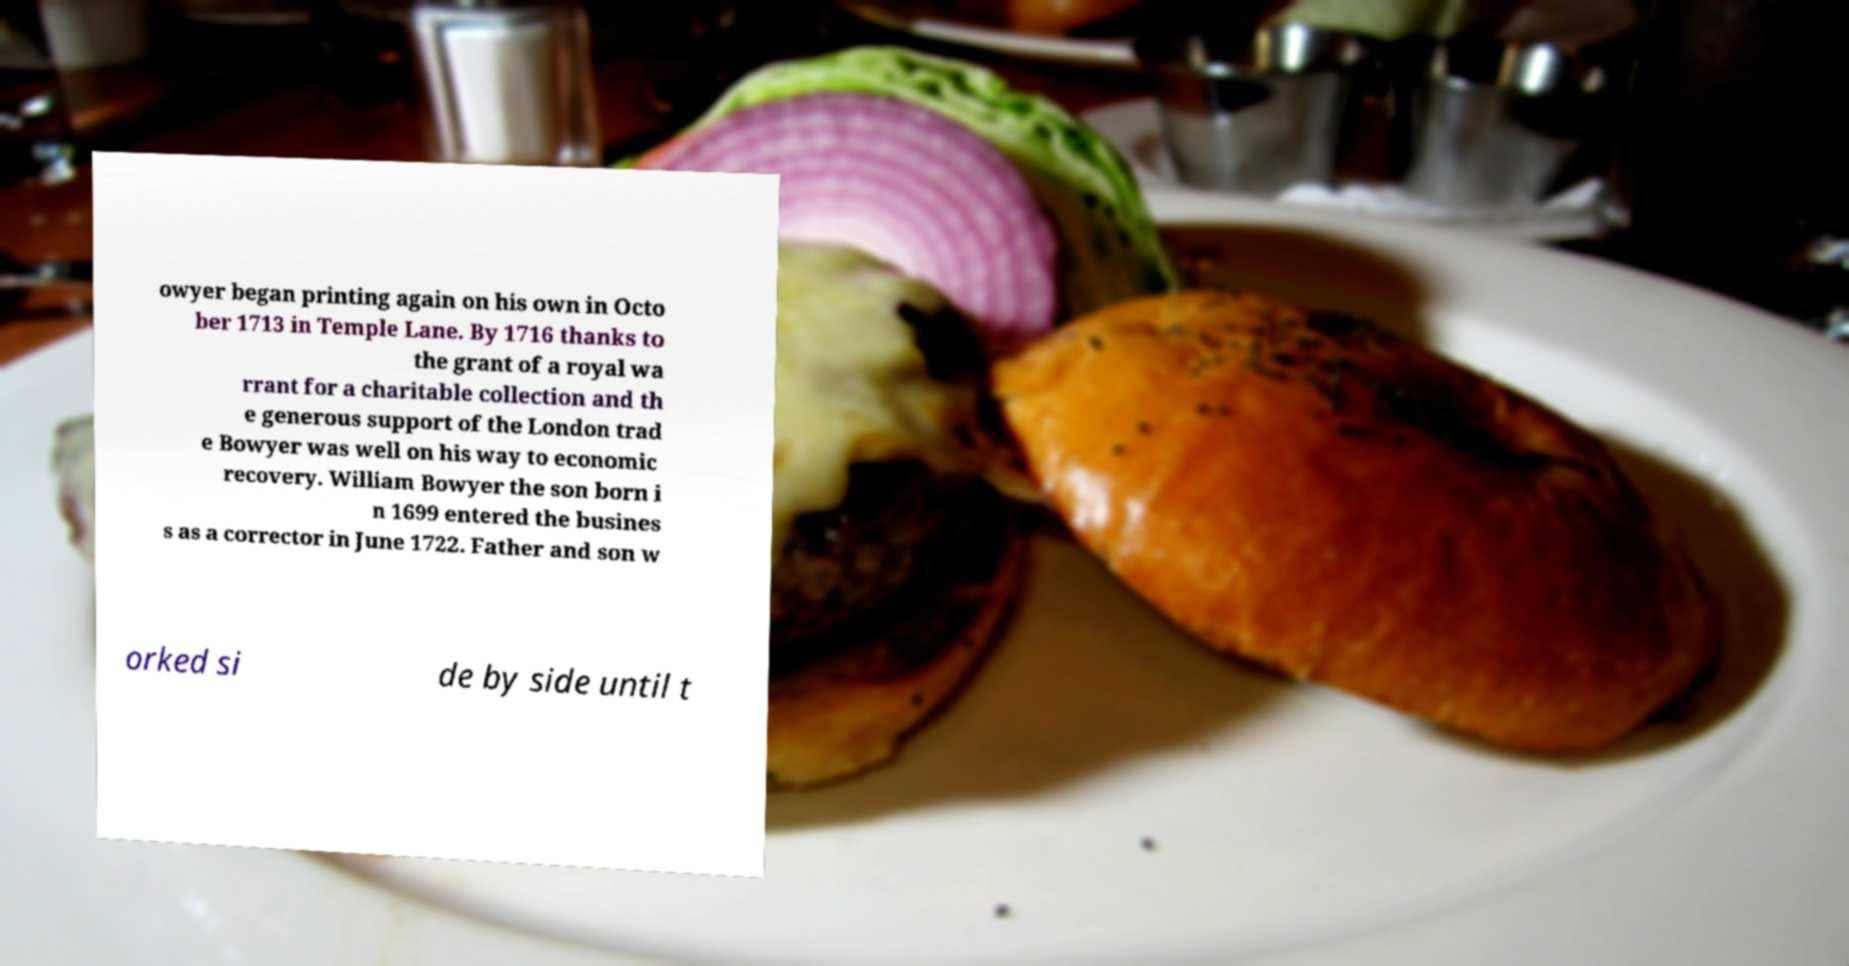I need the written content from this picture converted into text. Can you do that? owyer began printing again on his own in Octo ber 1713 in Temple Lane. By 1716 thanks to the grant of a royal wa rrant for a charitable collection and th e generous support of the London trad e Bowyer was well on his way to economic recovery. William Bowyer the son born i n 1699 entered the busines s as a corrector in June 1722. Father and son w orked si de by side until t 